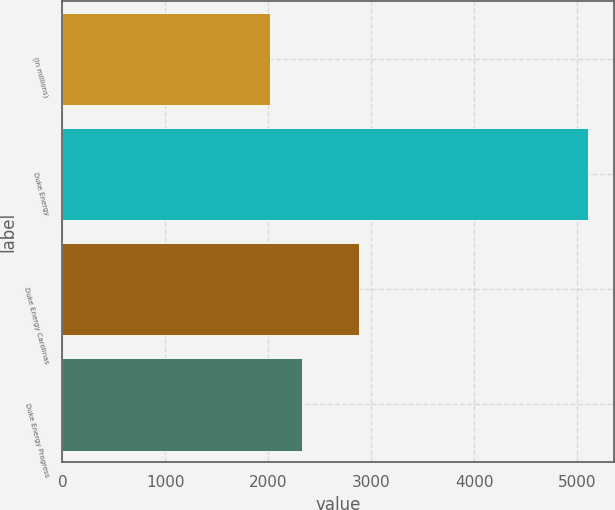Convert chart. <chart><loc_0><loc_0><loc_500><loc_500><bar_chart><fcel>(in millions)<fcel>Duke Energy<fcel>Duke Energy Carolinas<fcel>Duke Energy Progress<nl><fcel>2016<fcel>5099<fcel>2882<fcel>2324.3<nl></chart> 